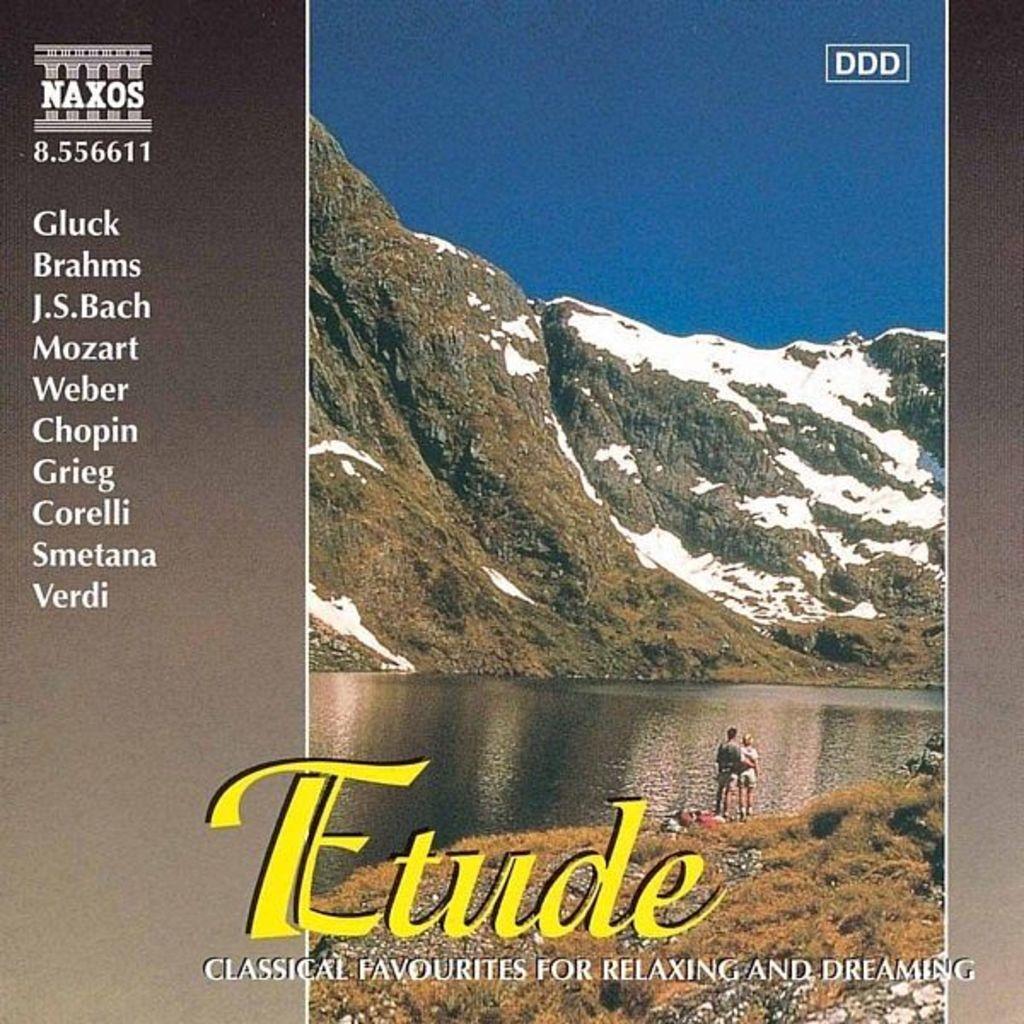What kind of music is this?
Provide a short and direct response. Classical. What is the last composer listed in the column?
Your response must be concise. Verdi. 